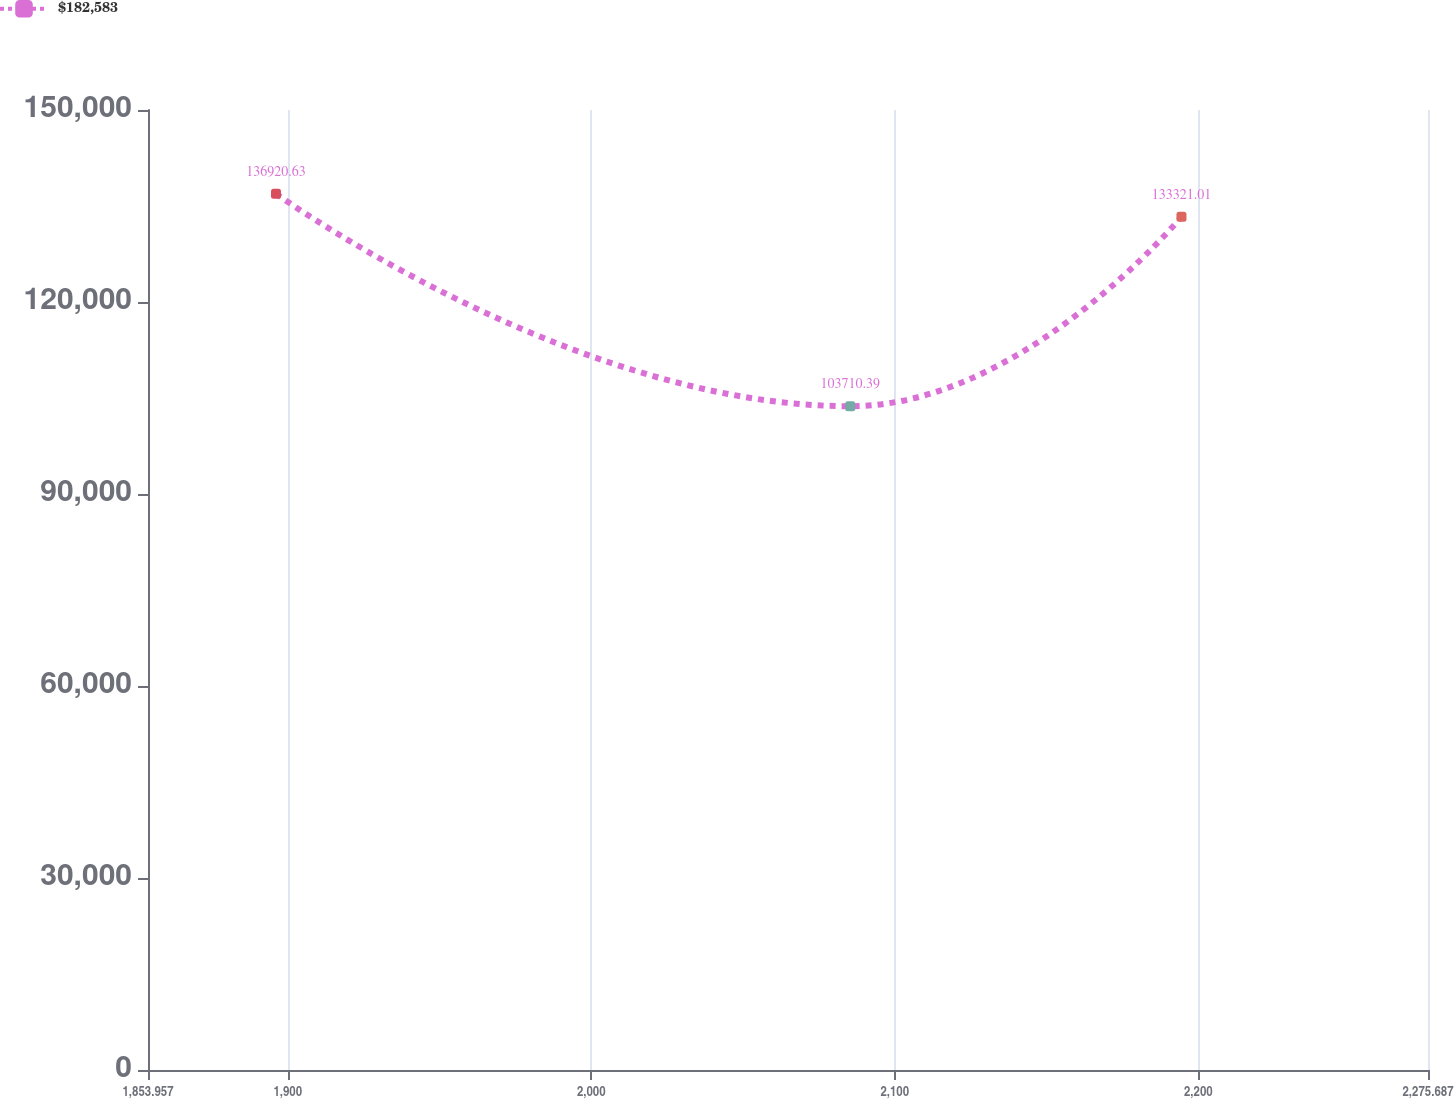<chart> <loc_0><loc_0><loc_500><loc_500><line_chart><ecel><fcel>$182,583<nl><fcel>1896.13<fcel>136921<nl><fcel>2085.33<fcel>103710<nl><fcel>2194.46<fcel>133321<nl><fcel>2317.86<fcel>99271.6<nl></chart> 